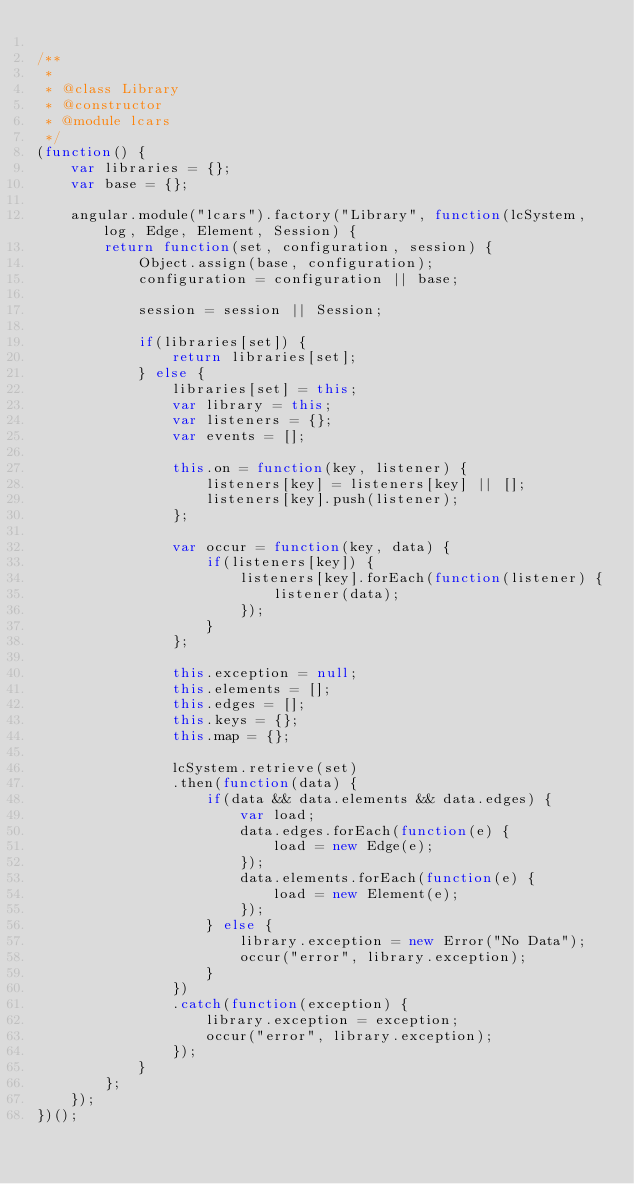Convert code to text. <code><loc_0><loc_0><loc_500><loc_500><_JavaScript_>
/**
 * 
 * @class Library
 * @constructor
 * @module lcars
 */
(function() {
	var libraries = {};
	var base = {};
	
	angular.module("lcars").factory("Library", function(lcSystem, log, Edge, Element, Session) {
		return function(set, configuration, session) {
			Object.assign(base, configuration);
			configuration = configuration || base;
			
			session = session || Session;
			
			if(libraries[set]) {
				return libraries[set];
			} else {
				libraries[set] = this;
				var library = this;
				var listeners = {};
				var events = [];
	
				this.on = function(key, listener) {
					listeners[key] = listeners[key] || [];
					listeners[key].push(listener);
				};
	
				var occur = function(key, data) {
					if(listeners[key]) {
						listeners[key].forEach(function(listener) {
							listener(data);
						});
					}
				};
	
				this.exception = null;
				this.elements = [];
				this.edges = [];
				this.keys = {};
				this.map = {};
	
				lcSystem.retrieve(set)
				.then(function(data) {
					if(data && data.elements && data.edges) {
						var load;
						data.edges.forEach(function(e) {
							load = new Edge(e);
						});
						data.elements.forEach(function(e) {
							load = new Element(e);
						});
					} else {
						library.exception = new Error("No Data");
						occur("error", library.exception);
					}
				})
				.catch(function(exception) {
					library.exception = exception;
					occur("error", library.exception);
				});
			}
		};
	});
})();
</code> 